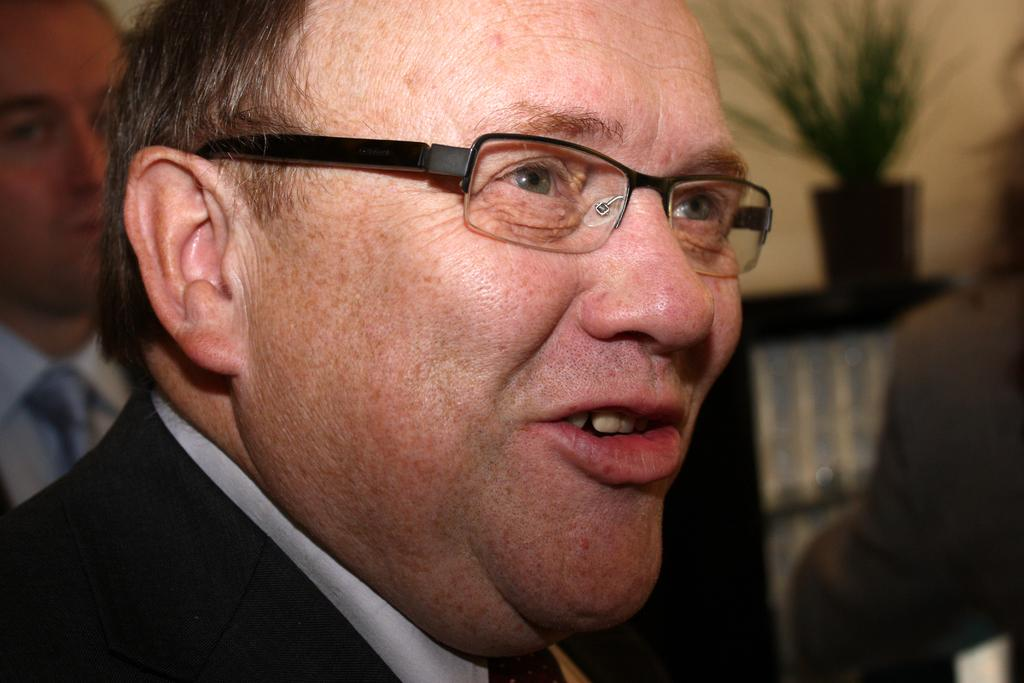What is the appearance of the person in the image? The person in the image is wearing a black suit and spectacles. What is the person in the image doing? The person is speaking. Are there any other people in the image? Yes, there is another person in the image. What type of magic is the person performing in the image? There is no indication of magic or any magical activity in the image. 